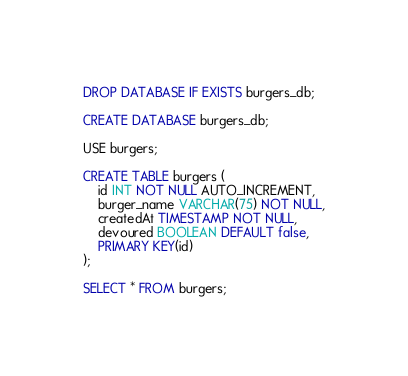<code> <loc_0><loc_0><loc_500><loc_500><_SQL_>DROP DATABASE IF EXISTS burgers_db;

CREATE DATABASE burgers_db;

USE burgers;

CREATE TABLE burgers (
    id INT NOT NULL AUTO_INCREMENT,
    burger_name VARCHAR(75) NOT NULL,
    createdAt TIMESTAMP NOT NULL,
	devoured BOOLEAN DEFAULT false,
    PRIMARY KEY(id)
);

SELECT * FROM burgers;</code> 